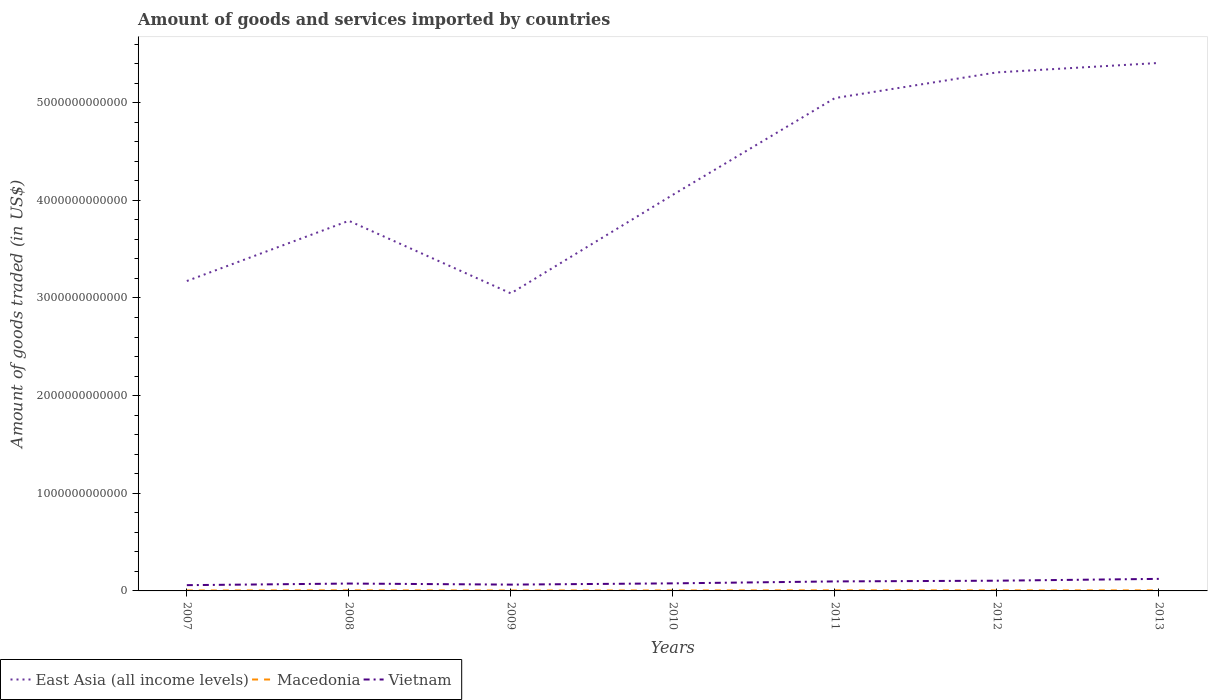Is the number of lines equal to the number of legend labels?
Your response must be concise. Yes. Across all years, what is the maximum total amount of goods and services imported in Macedonia?
Offer a terse response. 4.31e+09. What is the total total amount of goods and services imported in Vietnam in the graph?
Offer a very short reply. 1.08e+1. What is the difference between the highest and the second highest total amount of goods and services imported in Macedonia?
Your answer should be very brief. 1.67e+09. What is the difference between the highest and the lowest total amount of goods and services imported in Vietnam?
Offer a very short reply. 3. What is the difference between two consecutive major ticks on the Y-axis?
Offer a terse response. 1.00e+12. Are the values on the major ticks of Y-axis written in scientific E-notation?
Offer a terse response. No. Does the graph contain any zero values?
Ensure brevity in your answer.  No. How many legend labels are there?
Provide a succinct answer. 3. What is the title of the graph?
Provide a short and direct response. Amount of goods and services imported by countries. Does "Georgia" appear as one of the legend labels in the graph?
Provide a succinct answer. No. What is the label or title of the Y-axis?
Your answer should be very brief. Amount of goods traded (in US$). What is the Amount of goods traded (in US$) of East Asia (all income levels) in 2007?
Make the answer very short. 3.17e+12. What is the Amount of goods traded (in US$) of Macedonia in 2007?
Offer a very short reply. 4.43e+09. What is the Amount of goods traded (in US$) in Vietnam in 2007?
Offer a very short reply. 5.90e+1. What is the Amount of goods traded (in US$) of East Asia (all income levels) in 2008?
Offer a very short reply. 3.79e+12. What is the Amount of goods traded (in US$) of Macedonia in 2008?
Offer a terse response. 5.84e+09. What is the Amount of goods traded (in US$) in Vietnam in 2008?
Your answer should be compact. 7.55e+1. What is the Amount of goods traded (in US$) in East Asia (all income levels) in 2009?
Provide a succinct answer. 3.05e+12. What is the Amount of goods traded (in US$) in Macedonia in 2009?
Your answer should be very brief. 4.31e+09. What is the Amount of goods traded (in US$) in Vietnam in 2009?
Make the answer very short. 6.47e+1. What is the Amount of goods traded (in US$) in East Asia (all income levels) in 2010?
Make the answer very short. 4.06e+12. What is the Amount of goods traded (in US$) of Macedonia in 2010?
Offer a very short reply. 4.65e+09. What is the Amount of goods traded (in US$) of Vietnam in 2010?
Ensure brevity in your answer.  7.74e+1. What is the Amount of goods traded (in US$) of East Asia (all income levels) in 2011?
Keep it short and to the point. 5.05e+12. What is the Amount of goods traded (in US$) in Macedonia in 2011?
Your answer should be compact. 5.98e+09. What is the Amount of goods traded (in US$) in Vietnam in 2011?
Offer a very short reply. 9.74e+1. What is the Amount of goods traded (in US$) in East Asia (all income levels) in 2012?
Provide a succinct answer. 5.31e+12. What is the Amount of goods traded (in US$) of Macedonia in 2012?
Provide a succinct answer. 5.54e+09. What is the Amount of goods traded (in US$) of Vietnam in 2012?
Provide a succinct answer. 1.05e+11. What is the Amount of goods traded (in US$) of East Asia (all income levels) in 2013?
Provide a succinct answer. 5.41e+12. What is the Amount of goods traded (in US$) in Macedonia in 2013?
Provide a short and direct response. 5.63e+09. What is the Amount of goods traded (in US$) of Vietnam in 2013?
Your response must be concise. 1.23e+11. Across all years, what is the maximum Amount of goods traded (in US$) in East Asia (all income levels)?
Your answer should be compact. 5.41e+12. Across all years, what is the maximum Amount of goods traded (in US$) in Macedonia?
Your answer should be compact. 5.98e+09. Across all years, what is the maximum Amount of goods traded (in US$) of Vietnam?
Your answer should be compact. 1.23e+11. Across all years, what is the minimum Amount of goods traded (in US$) in East Asia (all income levels)?
Your answer should be very brief. 3.05e+12. Across all years, what is the minimum Amount of goods traded (in US$) in Macedonia?
Your answer should be compact. 4.31e+09. Across all years, what is the minimum Amount of goods traded (in US$) of Vietnam?
Provide a short and direct response. 5.90e+1. What is the total Amount of goods traded (in US$) in East Asia (all income levels) in the graph?
Make the answer very short. 2.98e+13. What is the total Amount of goods traded (in US$) in Macedonia in the graph?
Keep it short and to the point. 3.64e+1. What is the total Amount of goods traded (in US$) of Vietnam in the graph?
Provide a short and direct response. 6.02e+11. What is the difference between the Amount of goods traded (in US$) of East Asia (all income levels) in 2007 and that in 2008?
Your answer should be compact. -6.17e+11. What is the difference between the Amount of goods traded (in US$) in Macedonia in 2007 and that in 2008?
Keep it short and to the point. -1.40e+09. What is the difference between the Amount of goods traded (in US$) in Vietnam in 2007 and that in 2008?
Offer a very short reply. -1.65e+1. What is the difference between the Amount of goods traded (in US$) in East Asia (all income levels) in 2007 and that in 2009?
Your answer should be very brief. 1.26e+11. What is the difference between the Amount of goods traded (in US$) in Macedonia in 2007 and that in 2009?
Make the answer very short. 1.21e+08. What is the difference between the Amount of goods traded (in US$) of Vietnam in 2007 and that in 2009?
Your answer should be compact. -5.70e+09. What is the difference between the Amount of goods traded (in US$) in East Asia (all income levels) in 2007 and that in 2010?
Keep it short and to the point. -8.83e+11. What is the difference between the Amount of goods traded (in US$) in Macedonia in 2007 and that in 2010?
Offer a very short reply. -2.15e+08. What is the difference between the Amount of goods traded (in US$) in Vietnam in 2007 and that in 2010?
Your response must be concise. -1.84e+1. What is the difference between the Amount of goods traded (in US$) in East Asia (all income levels) in 2007 and that in 2011?
Give a very brief answer. -1.87e+12. What is the difference between the Amount of goods traded (in US$) of Macedonia in 2007 and that in 2011?
Offer a terse response. -1.55e+09. What is the difference between the Amount of goods traded (in US$) of Vietnam in 2007 and that in 2011?
Your answer should be compact. -3.84e+1. What is the difference between the Amount of goods traded (in US$) of East Asia (all income levels) in 2007 and that in 2012?
Ensure brevity in your answer.  -2.14e+12. What is the difference between the Amount of goods traded (in US$) in Macedonia in 2007 and that in 2012?
Provide a succinct answer. -1.11e+09. What is the difference between the Amount of goods traded (in US$) in Vietnam in 2007 and that in 2012?
Give a very brief answer. -4.57e+1. What is the difference between the Amount of goods traded (in US$) of East Asia (all income levels) in 2007 and that in 2013?
Ensure brevity in your answer.  -2.23e+12. What is the difference between the Amount of goods traded (in US$) in Macedonia in 2007 and that in 2013?
Keep it short and to the point. -1.20e+09. What is the difference between the Amount of goods traded (in US$) in Vietnam in 2007 and that in 2013?
Provide a short and direct response. -6.44e+1. What is the difference between the Amount of goods traded (in US$) in East Asia (all income levels) in 2008 and that in 2009?
Offer a terse response. 7.43e+11. What is the difference between the Amount of goods traded (in US$) of Macedonia in 2008 and that in 2009?
Make the answer very short. 1.53e+09. What is the difference between the Amount of goods traded (in US$) in Vietnam in 2008 and that in 2009?
Offer a terse response. 1.08e+1. What is the difference between the Amount of goods traded (in US$) of East Asia (all income levels) in 2008 and that in 2010?
Ensure brevity in your answer.  -2.66e+11. What is the difference between the Amount of goods traded (in US$) in Macedonia in 2008 and that in 2010?
Ensure brevity in your answer.  1.19e+09. What is the difference between the Amount of goods traded (in US$) of Vietnam in 2008 and that in 2010?
Your answer should be compact. -1.90e+09. What is the difference between the Amount of goods traded (in US$) in East Asia (all income levels) in 2008 and that in 2011?
Make the answer very short. -1.26e+12. What is the difference between the Amount of goods traded (in US$) in Macedonia in 2008 and that in 2011?
Offer a terse response. -1.41e+08. What is the difference between the Amount of goods traded (in US$) in Vietnam in 2008 and that in 2011?
Offer a very short reply. -2.19e+1. What is the difference between the Amount of goods traded (in US$) of East Asia (all income levels) in 2008 and that in 2012?
Ensure brevity in your answer.  -1.52e+12. What is the difference between the Amount of goods traded (in US$) in Macedonia in 2008 and that in 2012?
Provide a succinct answer. 2.94e+08. What is the difference between the Amount of goods traded (in US$) of Vietnam in 2008 and that in 2012?
Your answer should be very brief. -2.92e+1. What is the difference between the Amount of goods traded (in US$) of East Asia (all income levels) in 2008 and that in 2013?
Ensure brevity in your answer.  -1.62e+12. What is the difference between the Amount of goods traded (in US$) of Macedonia in 2008 and that in 2013?
Give a very brief answer. 2.04e+08. What is the difference between the Amount of goods traded (in US$) in Vietnam in 2008 and that in 2013?
Provide a short and direct response. -4.79e+1. What is the difference between the Amount of goods traded (in US$) of East Asia (all income levels) in 2009 and that in 2010?
Your answer should be compact. -1.01e+12. What is the difference between the Amount of goods traded (in US$) in Macedonia in 2009 and that in 2010?
Provide a succinct answer. -3.35e+08. What is the difference between the Amount of goods traded (in US$) of Vietnam in 2009 and that in 2010?
Keep it short and to the point. -1.27e+1. What is the difference between the Amount of goods traded (in US$) in East Asia (all income levels) in 2009 and that in 2011?
Ensure brevity in your answer.  -2.00e+12. What is the difference between the Amount of goods traded (in US$) of Macedonia in 2009 and that in 2011?
Ensure brevity in your answer.  -1.67e+09. What is the difference between the Amount of goods traded (in US$) in Vietnam in 2009 and that in 2011?
Offer a very short reply. -3.27e+1. What is the difference between the Amount of goods traded (in US$) of East Asia (all income levels) in 2009 and that in 2012?
Your answer should be compact. -2.26e+12. What is the difference between the Amount of goods traded (in US$) in Macedonia in 2009 and that in 2012?
Make the answer very short. -1.23e+09. What is the difference between the Amount of goods traded (in US$) of Vietnam in 2009 and that in 2012?
Provide a succinct answer. -4.00e+1. What is the difference between the Amount of goods traded (in US$) in East Asia (all income levels) in 2009 and that in 2013?
Offer a very short reply. -2.36e+12. What is the difference between the Amount of goods traded (in US$) in Macedonia in 2009 and that in 2013?
Make the answer very short. -1.32e+09. What is the difference between the Amount of goods traded (in US$) of Vietnam in 2009 and that in 2013?
Ensure brevity in your answer.  -5.87e+1. What is the difference between the Amount of goods traded (in US$) in East Asia (all income levels) in 2010 and that in 2011?
Ensure brevity in your answer.  -9.90e+11. What is the difference between the Amount of goods traded (in US$) in Macedonia in 2010 and that in 2011?
Your answer should be very brief. -1.33e+09. What is the difference between the Amount of goods traded (in US$) in Vietnam in 2010 and that in 2011?
Give a very brief answer. -2.00e+1. What is the difference between the Amount of goods traded (in US$) in East Asia (all income levels) in 2010 and that in 2012?
Provide a succinct answer. -1.25e+12. What is the difference between the Amount of goods traded (in US$) of Macedonia in 2010 and that in 2012?
Offer a very short reply. -8.96e+08. What is the difference between the Amount of goods traded (in US$) of Vietnam in 2010 and that in 2012?
Ensure brevity in your answer.  -2.73e+1. What is the difference between the Amount of goods traded (in US$) in East Asia (all income levels) in 2010 and that in 2013?
Your answer should be very brief. -1.35e+12. What is the difference between the Amount of goods traded (in US$) of Macedonia in 2010 and that in 2013?
Offer a very short reply. -9.86e+08. What is the difference between the Amount of goods traded (in US$) of Vietnam in 2010 and that in 2013?
Give a very brief answer. -4.60e+1. What is the difference between the Amount of goods traded (in US$) of East Asia (all income levels) in 2011 and that in 2012?
Make the answer very short. -2.63e+11. What is the difference between the Amount of goods traded (in US$) of Macedonia in 2011 and that in 2012?
Give a very brief answer. 4.35e+08. What is the difference between the Amount of goods traded (in US$) of Vietnam in 2011 and that in 2012?
Offer a terse response. -7.33e+09. What is the difference between the Amount of goods traded (in US$) of East Asia (all income levels) in 2011 and that in 2013?
Your answer should be compact. -3.60e+11. What is the difference between the Amount of goods traded (in US$) of Macedonia in 2011 and that in 2013?
Your answer should be very brief. 3.46e+08. What is the difference between the Amount of goods traded (in US$) of Vietnam in 2011 and that in 2013?
Your answer should be very brief. -2.60e+1. What is the difference between the Amount of goods traded (in US$) in East Asia (all income levels) in 2012 and that in 2013?
Offer a terse response. -9.66e+1. What is the difference between the Amount of goods traded (in US$) in Macedonia in 2012 and that in 2013?
Provide a short and direct response. -8.96e+07. What is the difference between the Amount of goods traded (in US$) of Vietnam in 2012 and that in 2013?
Offer a terse response. -1.87e+1. What is the difference between the Amount of goods traded (in US$) in East Asia (all income levels) in 2007 and the Amount of goods traded (in US$) in Macedonia in 2008?
Ensure brevity in your answer.  3.17e+12. What is the difference between the Amount of goods traded (in US$) of East Asia (all income levels) in 2007 and the Amount of goods traded (in US$) of Vietnam in 2008?
Offer a very short reply. 3.10e+12. What is the difference between the Amount of goods traded (in US$) of Macedonia in 2007 and the Amount of goods traded (in US$) of Vietnam in 2008?
Your answer should be compact. -7.10e+1. What is the difference between the Amount of goods traded (in US$) of East Asia (all income levels) in 2007 and the Amount of goods traded (in US$) of Macedonia in 2009?
Your answer should be compact. 3.17e+12. What is the difference between the Amount of goods traded (in US$) in East Asia (all income levels) in 2007 and the Amount of goods traded (in US$) in Vietnam in 2009?
Provide a succinct answer. 3.11e+12. What is the difference between the Amount of goods traded (in US$) of Macedonia in 2007 and the Amount of goods traded (in US$) of Vietnam in 2009?
Your answer should be very brief. -6.03e+1. What is the difference between the Amount of goods traded (in US$) of East Asia (all income levels) in 2007 and the Amount of goods traded (in US$) of Macedonia in 2010?
Your answer should be very brief. 3.17e+12. What is the difference between the Amount of goods traded (in US$) in East Asia (all income levels) in 2007 and the Amount of goods traded (in US$) in Vietnam in 2010?
Give a very brief answer. 3.10e+12. What is the difference between the Amount of goods traded (in US$) of Macedonia in 2007 and the Amount of goods traded (in US$) of Vietnam in 2010?
Keep it short and to the point. -7.29e+1. What is the difference between the Amount of goods traded (in US$) of East Asia (all income levels) in 2007 and the Amount of goods traded (in US$) of Macedonia in 2011?
Your response must be concise. 3.17e+12. What is the difference between the Amount of goods traded (in US$) in East Asia (all income levels) in 2007 and the Amount of goods traded (in US$) in Vietnam in 2011?
Offer a very short reply. 3.08e+12. What is the difference between the Amount of goods traded (in US$) in Macedonia in 2007 and the Amount of goods traded (in US$) in Vietnam in 2011?
Offer a terse response. -9.29e+1. What is the difference between the Amount of goods traded (in US$) of East Asia (all income levels) in 2007 and the Amount of goods traded (in US$) of Macedonia in 2012?
Keep it short and to the point. 3.17e+12. What is the difference between the Amount of goods traded (in US$) in East Asia (all income levels) in 2007 and the Amount of goods traded (in US$) in Vietnam in 2012?
Your answer should be very brief. 3.07e+12. What is the difference between the Amount of goods traded (in US$) in Macedonia in 2007 and the Amount of goods traded (in US$) in Vietnam in 2012?
Offer a very short reply. -1.00e+11. What is the difference between the Amount of goods traded (in US$) of East Asia (all income levels) in 2007 and the Amount of goods traded (in US$) of Macedonia in 2013?
Ensure brevity in your answer.  3.17e+12. What is the difference between the Amount of goods traded (in US$) in East Asia (all income levels) in 2007 and the Amount of goods traded (in US$) in Vietnam in 2013?
Your response must be concise. 3.05e+12. What is the difference between the Amount of goods traded (in US$) in Macedonia in 2007 and the Amount of goods traded (in US$) in Vietnam in 2013?
Provide a succinct answer. -1.19e+11. What is the difference between the Amount of goods traded (in US$) of East Asia (all income levels) in 2008 and the Amount of goods traded (in US$) of Macedonia in 2009?
Give a very brief answer. 3.79e+12. What is the difference between the Amount of goods traded (in US$) of East Asia (all income levels) in 2008 and the Amount of goods traded (in US$) of Vietnam in 2009?
Keep it short and to the point. 3.73e+12. What is the difference between the Amount of goods traded (in US$) of Macedonia in 2008 and the Amount of goods traded (in US$) of Vietnam in 2009?
Make the answer very short. -5.89e+1. What is the difference between the Amount of goods traded (in US$) in East Asia (all income levels) in 2008 and the Amount of goods traded (in US$) in Macedonia in 2010?
Offer a very short reply. 3.79e+12. What is the difference between the Amount of goods traded (in US$) in East Asia (all income levels) in 2008 and the Amount of goods traded (in US$) in Vietnam in 2010?
Keep it short and to the point. 3.71e+12. What is the difference between the Amount of goods traded (in US$) of Macedonia in 2008 and the Amount of goods traded (in US$) of Vietnam in 2010?
Ensure brevity in your answer.  -7.15e+1. What is the difference between the Amount of goods traded (in US$) in East Asia (all income levels) in 2008 and the Amount of goods traded (in US$) in Macedonia in 2011?
Your answer should be very brief. 3.78e+12. What is the difference between the Amount of goods traded (in US$) of East Asia (all income levels) in 2008 and the Amount of goods traded (in US$) of Vietnam in 2011?
Make the answer very short. 3.69e+12. What is the difference between the Amount of goods traded (in US$) in Macedonia in 2008 and the Amount of goods traded (in US$) in Vietnam in 2011?
Your answer should be very brief. -9.15e+1. What is the difference between the Amount of goods traded (in US$) in East Asia (all income levels) in 2008 and the Amount of goods traded (in US$) in Macedonia in 2012?
Offer a terse response. 3.78e+12. What is the difference between the Amount of goods traded (in US$) in East Asia (all income levels) in 2008 and the Amount of goods traded (in US$) in Vietnam in 2012?
Offer a terse response. 3.69e+12. What is the difference between the Amount of goods traded (in US$) in Macedonia in 2008 and the Amount of goods traded (in US$) in Vietnam in 2012?
Make the answer very short. -9.88e+1. What is the difference between the Amount of goods traded (in US$) in East Asia (all income levels) in 2008 and the Amount of goods traded (in US$) in Macedonia in 2013?
Your answer should be very brief. 3.78e+12. What is the difference between the Amount of goods traded (in US$) of East Asia (all income levels) in 2008 and the Amount of goods traded (in US$) of Vietnam in 2013?
Provide a short and direct response. 3.67e+12. What is the difference between the Amount of goods traded (in US$) of Macedonia in 2008 and the Amount of goods traded (in US$) of Vietnam in 2013?
Your answer should be compact. -1.18e+11. What is the difference between the Amount of goods traded (in US$) of East Asia (all income levels) in 2009 and the Amount of goods traded (in US$) of Macedonia in 2010?
Offer a terse response. 3.04e+12. What is the difference between the Amount of goods traded (in US$) in East Asia (all income levels) in 2009 and the Amount of goods traded (in US$) in Vietnam in 2010?
Ensure brevity in your answer.  2.97e+12. What is the difference between the Amount of goods traded (in US$) in Macedonia in 2009 and the Amount of goods traded (in US$) in Vietnam in 2010?
Keep it short and to the point. -7.31e+1. What is the difference between the Amount of goods traded (in US$) in East Asia (all income levels) in 2009 and the Amount of goods traded (in US$) in Macedonia in 2011?
Your answer should be compact. 3.04e+12. What is the difference between the Amount of goods traded (in US$) of East Asia (all income levels) in 2009 and the Amount of goods traded (in US$) of Vietnam in 2011?
Provide a succinct answer. 2.95e+12. What is the difference between the Amount of goods traded (in US$) in Macedonia in 2009 and the Amount of goods traded (in US$) in Vietnam in 2011?
Make the answer very short. -9.30e+1. What is the difference between the Amount of goods traded (in US$) of East Asia (all income levels) in 2009 and the Amount of goods traded (in US$) of Macedonia in 2012?
Ensure brevity in your answer.  3.04e+12. What is the difference between the Amount of goods traded (in US$) of East Asia (all income levels) in 2009 and the Amount of goods traded (in US$) of Vietnam in 2012?
Your answer should be very brief. 2.94e+12. What is the difference between the Amount of goods traded (in US$) in Macedonia in 2009 and the Amount of goods traded (in US$) in Vietnam in 2012?
Your answer should be very brief. -1.00e+11. What is the difference between the Amount of goods traded (in US$) of East Asia (all income levels) in 2009 and the Amount of goods traded (in US$) of Macedonia in 2013?
Offer a terse response. 3.04e+12. What is the difference between the Amount of goods traded (in US$) in East Asia (all income levels) in 2009 and the Amount of goods traded (in US$) in Vietnam in 2013?
Ensure brevity in your answer.  2.92e+12. What is the difference between the Amount of goods traded (in US$) in Macedonia in 2009 and the Amount of goods traded (in US$) in Vietnam in 2013?
Give a very brief answer. -1.19e+11. What is the difference between the Amount of goods traded (in US$) of East Asia (all income levels) in 2010 and the Amount of goods traded (in US$) of Macedonia in 2011?
Keep it short and to the point. 4.05e+12. What is the difference between the Amount of goods traded (in US$) in East Asia (all income levels) in 2010 and the Amount of goods traded (in US$) in Vietnam in 2011?
Your response must be concise. 3.96e+12. What is the difference between the Amount of goods traded (in US$) in Macedonia in 2010 and the Amount of goods traded (in US$) in Vietnam in 2011?
Your answer should be very brief. -9.27e+1. What is the difference between the Amount of goods traded (in US$) in East Asia (all income levels) in 2010 and the Amount of goods traded (in US$) in Macedonia in 2012?
Make the answer very short. 4.05e+12. What is the difference between the Amount of goods traded (in US$) of East Asia (all income levels) in 2010 and the Amount of goods traded (in US$) of Vietnam in 2012?
Your response must be concise. 3.95e+12. What is the difference between the Amount of goods traded (in US$) in Macedonia in 2010 and the Amount of goods traded (in US$) in Vietnam in 2012?
Keep it short and to the point. -1.00e+11. What is the difference between the Amount of goods traded (in US$) of East Asia (all income levels) in 2010 and the Amount of goods traded (in US$) of Macedonia in 2013?
Ensure brevity in your answer.  4.05e+12. What is the difference between the Amount of goods traded (in US$) of East Asia (all income levels) in 2010 and the Amount of goods traded (in US$) of Vietnam in 2013?
Offer a very short reply. 3.93e+12. What is the difference between the Amount of goods traded (in US$) in Macedonia in 2010 and the Amount of goods traded (in US$) in Vietnam in 2013?
Ensure brevity in your answer.  -1.19e+11. What is the difference between the Amount of goods traded (in US$) in East Asia (all income levels) in 2011 and the Amount of goods traded (in US$) in Macedonia in 2012?
Your answer should be very brief. 5.04e+12. What is the difference between the Amount of goods traded (in US$) of East Asia (all income levels) in 2011 and the Amount of goods traded (in US$) of Vietnam in 2012?
Offer a very short reply. 4.94e+12. What is the difference between the Amount of goods traded (in US$) in Macedonia in 2011 and the Amount of goods traded (in US$) in Vietnam in 2012?
Offer a very short reply. -9.87e+1. What is the difference between the Amount of goods traded (in US$) in East Asia (all income levels) in 2011 and the Amount of goods traded (in US$) in Macedonia in 2013?
Make the answer very short. 5.04e+12. What is the difference between the Amount of goods traded (in US$) in East Asia (all income levels) in 2011 and the Amount of goods traded (in US$) in Vietnam in 2013?
Give a very brief answer. 4.92e+12. What is the difference between the Amount of goods traded (in US$) of Macedonia in 2011 and the Amount of goods traded (in US$) of Vietnam in 2013?
Keep it short and to the point. -1.17e+11. What is the difference between the Amount of goods traded (in US$) in East Asia (all income levels) in 2012 and the Amount of goods traded (in US$) in Macedonia in 2013?
Ensure brevity in your answer.  5.30e+12. What is the difference between the Amount of goods traded (in US$) of East Asia (all income levels) in 2012 and the Amount of goods traded (in US$) of Vietnam in 2013?
Keep it short and to the point. 5.19e+12. What is the difference between the Amount of goods traded (in US$) in Macedonia in 2012 and the Amount of goods traded (in US$) in Vietnam in 2013?
Make the answer very short. -1.18e+11. What is the average Amount of goods traded (in US$) of East Asia (all income levels) per year?
Your answer should be compact. 4.26e+12. What is the average Amount of goods traded (in US$) of Macedonia per year?
Give a very brief answer. 5.20e+09. What is the average Amount of goods traded (in US$) of Vietnam per year?
Give a very brief answer. 8.60e+1. In the year 2007, what is the difference between the Amount of goods traded (in US$) in East Asia (all income levels) and Amount of goods traded (in US$) in Macedonia?
Provide a short and direct response. 3.17e+12. In the year 2007, what is the difference between the Amount of goods traded (in US$) of East Asia (all income levels) and Amount of goods traded (in US$) of Vietnam?
Keep it short and to the point. 3.11e+12. In the year 2007, what is the difference between the Amount of goods traded (in US$) of Macedonia and Amount of goods traded (in US$) of Vietnam?
Your answer should be compact. -5.46e+1. In the year 2008, what is the difference between the Amount of goods traded (in US$) of East Asia (all income levels) and Amount of goods traded (in US$) of Macedonia?
Give a very brief answer. 3.78e+12. In the year 2008, what is the difference between the Amount of goods traded (in US$) of East Asia (all income levels) and Amount of goods traded (in US$) of Vietnam?
Your answer should be very brief. 3.71e+12. In the year 2008, what is the difference between the Amount of goods traded (in US$) of Macedonia and Amount of goods traded (in US$) of Vietnam?
Ensure brevity in your answer.  -6.96e+1. In the year 2009, what is the difference between the Amount of goods traded (in US$) of East Asia (all income levels) and Amount of goods traded (in US$) of Macedonia?
Your answer should be very brief. 3.04e+12. In the year 2009, what is the difference between the Amount of goods traded (in US$) in East Asia (all income levels) and Amount of goods traded (in US$) in Vietnam?
Give a very brief answer. 2.98e+12. In the year 2009, what is the difference between the Amount of goods traded (in US$) of Macedonia and Amount of goods traded (in US$) of Vietnam?
Provide a succinct answer. -6.04e+1. In the year 2010, what is the difference between the Amount of goods traded (in US$) in East Asia (all income levels) and Amount of goods traded (in US$) in Macedonia?
Your answer should be very brief. 4.05e+12. In the year 2010, what is the difference between the Amount of goods traded (in US$) in East Asia (all income levels) and Amount of goods traded (in US$) in Vietnam?
Provide a short and direct response. 3.98e+12. In the year 2010, what is the difference between the Amount of goods traded (in US$) of Macedonia and Amount of goods traded (in US$) of Vietnam?
Offer a terse response. -7.27e+1. In the year 2011, what is the difference between the Amount of goods traded (in US$) of East Asia (all income levels) and Amount of goods traded (in US$) of Macedonia?
Offer a very short reply. 5.04e+12. In the year 2011, what is the difference between the Amount of goods traded (in US$) of East Asia (all income levels) and Amount of goods traded (in US$) of Vietnam?
Keep it short and to the point. 4.95e+12. In the year 2011, what is the difference between the Amount of goods traded (in US$) in Macedonia and Amount of goods traded (in US$) in Vietnam?
Give a very brief answer. -9.14e+1. In the year 2012, what is the difference between the Amount of goods traded (in US$) of East Asia (all income levels) and Amount of goods traded (in US$) of Macedonia?
Offer a terse response. 5.30e+12. In the year 2012, what is the difference between the Amount of goods traded (in US$) in East Asia (all income levels) and Amount of goods traded (in US$) in Vietnam?
Give a very brief answer. 5.21e+12. In the year 2012, what is the difference between the Amount of goods traded (in US$) in Macedonia and Amount of goods traded (in US$) in Vietnam?
Make the answer very short. -9.91e+1. In the year 2013, what is the difference between the Amount of goods traded (in US$) in East Asia (all income levels) and Amount of goods traded (in US$) in Macedonia?
Your answer should be compact. 5.40e+12. In the year 2013, what is the difference between the Amount of goods traded (in US$) in East Asia (all income levels) and Amount of goods traded (in US$) in Vietnam?
Your response must be concise. 5.28e+12. In the year 2013, what is the difference between the Amount of goods traded (in US$) in Macedonia and Amount of goods traded (in US$) in Vietnam?
Ensure brevity in your answer.  -1.18e+11. What is the ratio of the Amount of goods traded (in US$) of East Asia (all income levels) in 2007 to that in 2008?
Your answer should be very brief. 0.84. What is the ratio of the Amount of goods traded (in US$) of Macedonia in 2007 to that in 2008?
Give a very brief answer. 0.76. What is the ratio of the Amount of goods traded (in US$) in Vietnam in 2007 to that in 2008?
Your answer should be very brief. 0.78. What is the ratio of the Amount of goods traded (in US$) in East Asia (all income levels) in 2007 to that in 2009?
Ensure brevity in your answer.  1.04. What is the ratio of the Amount of goods traded (in US$) in Macedonia in 2007 to that in 2009?
Keep it short and to the point. 1.03. What is the ratio of the Amount of goods traded (in US$) in Vietnam in 2007 to that in 2009?
Keep it short and to the point. 0.91. What is the ratio of the Amount of goods traded (in US$) of East Asia (all income levels) in 2007 to that in 2010?
Provide a short and direct response. 0.78. What is the ratio of the Amount of goods traded (in US$) in Macedonia in 2007 to that in 2010?
Your response must be concise. 0.95. What is the ratio of the Amount of goods traded (in US$) of Vietnam in 2007 to that in 2010?
Ensure brevity in your answer.  0.76. What is the ratio of the Amount of goods traded (in US$) in East Asia (all income levels) in 2007 to that in 2011?
Give a very brief answer. 0.63. What is the ratio of the Amount of goods traded (in US$) of Macedonia in 2007 to that in 2011?
Offer a terse response. 0.74. What is the ratio of the Amount of goods traded (in US$) in Vietnam in 2007 to that in 2011?
Make the answer very short. 0.61. What is the ratio of the Amount of goods traded (in US$) in East Asia (all income levels) in 2007 to that in 2012?
Make the answer very short. 0.6. What is the ratio of the Amount of goods traded (in US$) in Macedonia in 2007 to that in 2012?
Give a very brief answer. 0.8. What is the ratio of the Amount of goods traded (in US$) in Vietnam in 2007 to that in 2012?
Keep it short and to the point. 0.56. What is the ratio of the Amount of goods traded (in US$) in East Asia (all income levels) in 2007 to that in 2013?
Offer a very short reply. 0.59. What is the ratio of the Amount of goods traded (in US$) in Macedonia in 2007 to that in 2013?
Provide a succinct answer. 0.79. What is the ratio of the Amount of goods traded (in US$) in Vietnam in 2007 to that in 2013?
Your response must be concise. 0.48. What is the ratio of the Amount of goods traded (in US$) in East Asia (all income levels) in 2008 to that in 2009?
Keep it short and to the point. 1.24. What is the ratio of the Amount of goods traded (in US$) in Macedonia in 2008 to that in 2009?
Provide a short and direct response. 1.35. What is the ratio of the Amount of goods traded (in US$) in Vietnam in 2008 to that in 2009?
Offer a terse response. 1.17. What is the ratio of the Amount of goods traded (in US$) of East Asia (all income levels) in 2008 to that in 2010?
Provide a succinct answer. 0.93. What is the ratio of the Amount of goods traded (in US$) of Macedonia in 2008 to that in 2010?
Provide a succinct answer. 1.26. What is the ratio of the Amount of goods traded (in US$) of Vietnam in 2008 to that in 2010?
Give a very brief answer. 0.98. What is the ratio of the Amount of goods traded (in US$) of East Asia (all income levels) in 2008 to that in 2011?
Provide a succinct answer. 0.75. What is the ratio of the Amount of goods traded (in US$) of Macedonia in 2008 to that in 2011?
Your answer should be compact. 0.98. What is the ratio of the Amount of goods traded (in US$) in Vietnam in 2008 to that in 2011?
Your response must be concise. 0.78. What is the ratio of the Amount of goods traded (in US$) of East Asia (all income levels) in 2008 to that in 2012?
Offer a terse response. 0.71. What is the ratio of the Amount of goods traded (in US$) in Macedonia in 2008 to that in 2012?
Give a very brief answer. 1.05. What is the ratio of the Amount of goods traded (in US$) in Vietnam in 2008 to that in 2012?
Keep it short and to the point. 0.72. What is the ratio of the Amount of goods traded (in US$) in East Asia (all income levels) in 2008 to that in 2013?
Provide a short and direct response. 0.7. What is the ratio of the Amount of goods traded (in US$) of Macedonia in 2008 to that in 2013?
Give a very brief answer. 1.04. What is the ratio of the Amount of goods traded (in US$) in Vietnam in 2008 to that in 2013?
Provide a succinct answer. 0.61. What is the ratio of the Amount of goods traded (in US$) of East Asia (all income levels) in 2009 to that in 2010?
Give a very brief answer. 0.75. What is the ratio of the Amount of goods traded (in US$) in Macedonia in 2009 to that in 2010?
Your answer should be very brief. 0.93. What is the ratio of the Amount of goods traded (in US$) of Vietnam in 2009 to that in 2010?
Your answer should be compact. 0.84. What is the ratio of the Amount of goods traded (in US$) in East Asia (all income levels) in 2009 to that in 2011?
Your answer should be very brief. 0.6. What is the ratio of the Amount of goods traded (in US$) of Macedonia in 2009 to that in 2011?
Offer a terse response. 0.72. What is the ratio of the Amount of goods traded (in US$) in Vietnam in 2009 to that in 2011?
Your answer should be compact. 0.66. What is the ratio of the Amount of goods traded (in US$) of East Asia (all income levels) in 2009 to that in 2012?
Ensure brevity in your answer.  0.57. What is the ratio of the Amount of goods traded (in US$) in Macedonia in 2009 to that in 2012?
Keep it short and to the point. 0.78. What is the ratio of the Amount of goods traded (in US$) in Vietnam in 2009 to that in 2012?
Offer a terse response. 0.62. What is the ratio of the Amount of goods traded (in US$) of East Asia (all income levels) in 2009 to that in 2013?
Ensure brevity in your answer.  0.56. What is the ratio of the Amount of goods traded (in US$) of Macedonia in 2009 to that in 2013?
Provide a short and direct response. 0.77. What is the ratio of the Amount of goods traded (in US$) in Vietnam in 2009 to that in 2013?
Offer a terse response. 0.52. What is the ratio of the Amount of goods traded (in US$) of East Asia (all income levels) in 2010 to that in 2011?
Your answer should be compact. 0.8. What is the ratio of the Amount of goods traded (in US$) of Macedonia in 2010 to that in 2011?
Your response must be concise. 0.78. What is the ratio of the Amount of goods traded (in US$) of Vietnam in 2010 to that in 2011?
Your response must be concise. 0.79. What is the ratio of the Amount of goods traded (in US$) of East Asia (all income levels) in 2010 to that in 2012?
Give a very brief answer. 0.76. What is the ratio of the Amount of goods traded (in US$) of Macedonia in 2010 to that in 2012?
Provide a short and direct response. 0.84. What is the ratio of the Amount of goods traded (in US$) of Vietnam in 2010 to that in 2012?
Offer a very short reply. 0.74. What is the ratio of the Amount of goods traded (in US$) in East Asia (all income levels) in 2010 to that in 2013?
Your response must be concise. 0.75. What is the ratio of the Amount of goods traded (in US$) of Macedonia in 2010 to that in 2013?
Provide a short and direct response. 0.83. What is the ratio of the Amount of goods traded (in US$) in Vietnam in 2010 to that in 2013?
Ensure brevity in your answer.  0.63. What is the ratio of the Amount of goods traded (in US$) in East Asia (all income levels) in 2011 to that in 2012?
Keep it short and to the point. 0.95. What is the ratio of the Amount of goods traded (in US$) of Macedonia in 2011 to that in 2012?
Make the answer very short. 1.08. What is the ratio of the Amount of goods traded (in US$) of Vietnam in 2011 to that in 2012?
Provide a succinct answer. 0.93. What is the ratio of the Amount of goods traded (in US$) of East Asia (all income levels) in 2011 to that in 2013?
Provide a short and direct response. 0.93. What is the ratio of the Amount of goods traded (in US$) in Macedonia in 2011 to that in 2013?
Offer a terse response. 1.06. What is the ratio of the Amount of goods traded (in US$) in Vietnam in 2011 to that in 2013?
Your answer should be compact. 0.79. What is the ratio of the Amount of goods traded (in US$) of East Asia (all income levels) in 2012 to that in 2013?
Make the answer very short. 0.98. What is the ratio of the Amount of goods traded (in US$) of Macedonia in 2012 to that in 2013?
Offer a very short reply. 0.98. What is the ratio of the Amount of goods traded (in US$) of Vietnam in 2012 to that in 2013?
Your answer should be very brief. 0.85. What is the difference between the highest and the second highest Amount of goods traded (in US$) of East Asia (all income levels)?
Keep it short and to the point. 9.66e+1. What is the difference between the highest and the second highest Amount of goods traded (in US$) of Macedonia?
Your answer should be very brief. 1.41e+08. What is the difference between the highest and the second highest Amount of goods traded (in US$) in Vietnam?
Your response must be concise. 1.87e+1. What is the difference between the highest and the lowest Amount of goods traded (in US$) of East Asia (all income levels)?
Keep it short and to the point. 2.36e+12. What is the difference between the highest and the lowest Amount of goods traded (in US$) of Macedonia?
Provide a succinct answer. 1.67e+09. What is the difference between the highest and the lowest Amount of goods traded (in US$) of Vietnam?
Your answer should be very brief. 6.44e+1. 